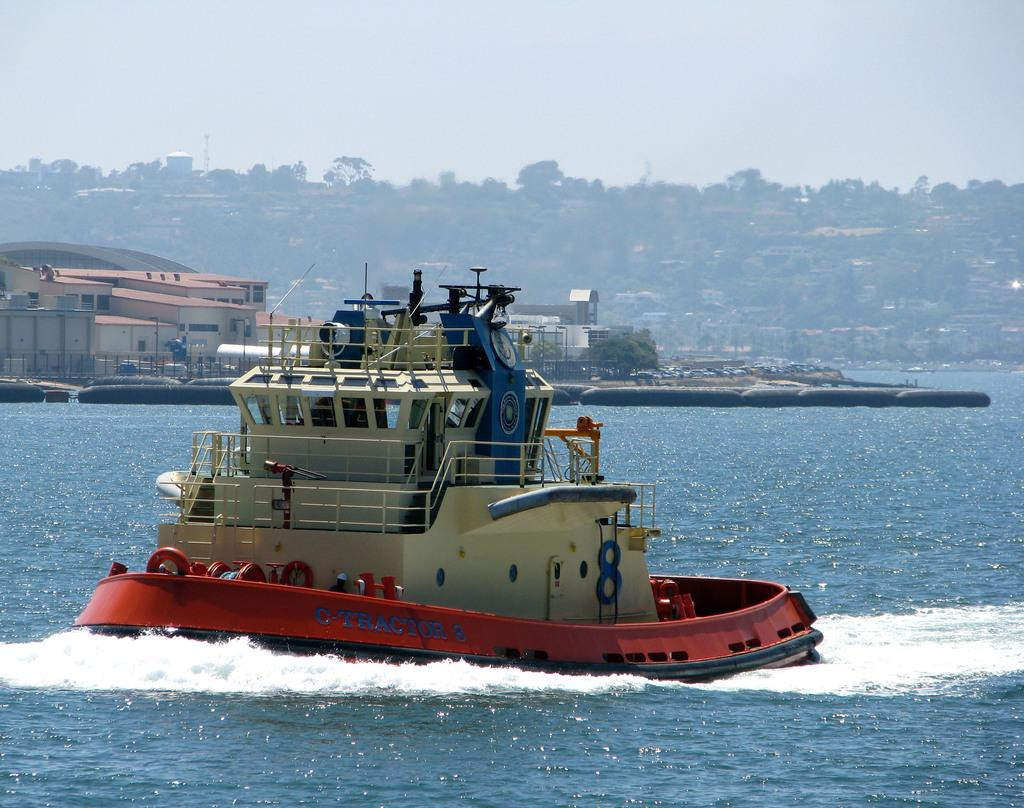What is the main subject of the image? The main subject of the subject of the image is a ship. Where is the ship located in the image? The ship is on the sea. What can be seen in the background of the image? In the background of the image, there are houses, a mountain, trees, and the sky. What type of songs is the goose singing in the image? There is no goose present in the image, so it is not possible to determine what songs it might be singing. 